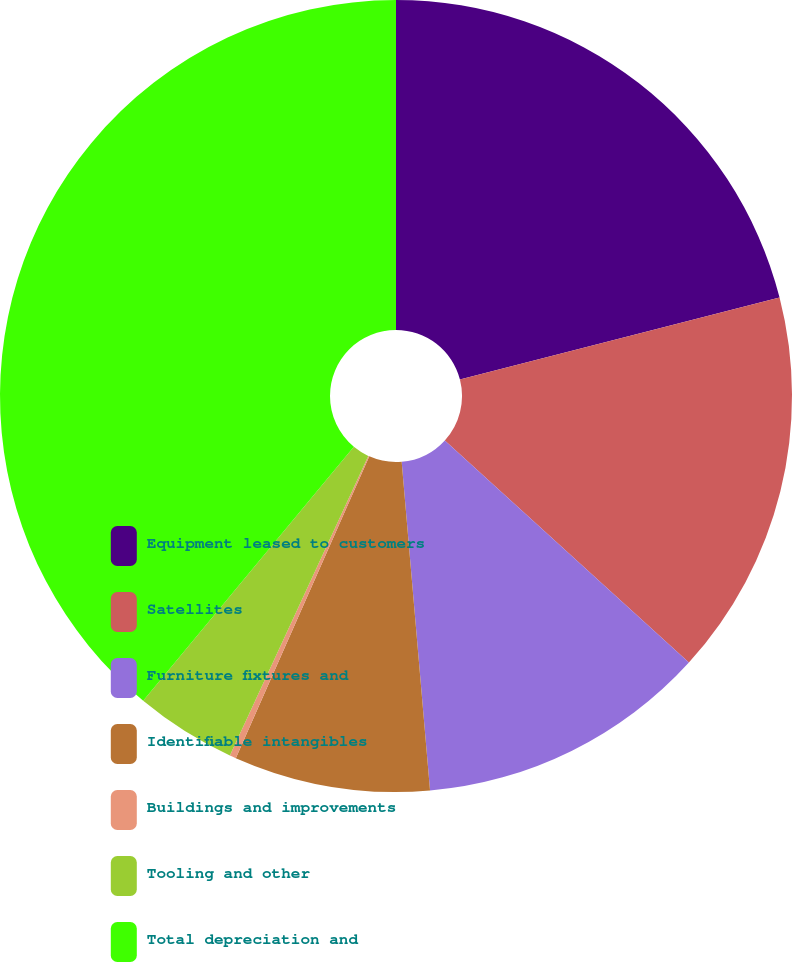Convert chart. <chart><loc_0><loc_0><loc_500><loc_500><pie_chart><fcel>Equipment leased to customers<fcel>Satellites<fcel>Furniture fixtures and<fcel>Identifiable intangibles<fcel>Buildings and improvements<fcel>Tooling and other<fcel>Total depreciation and<nl><fcel>21.0%<fcel>15.75%<fcel>11.88%<fcel>8.0%<fcel>0.26%<fcel>4.13%<fcel>38.98%<nl></chart> 